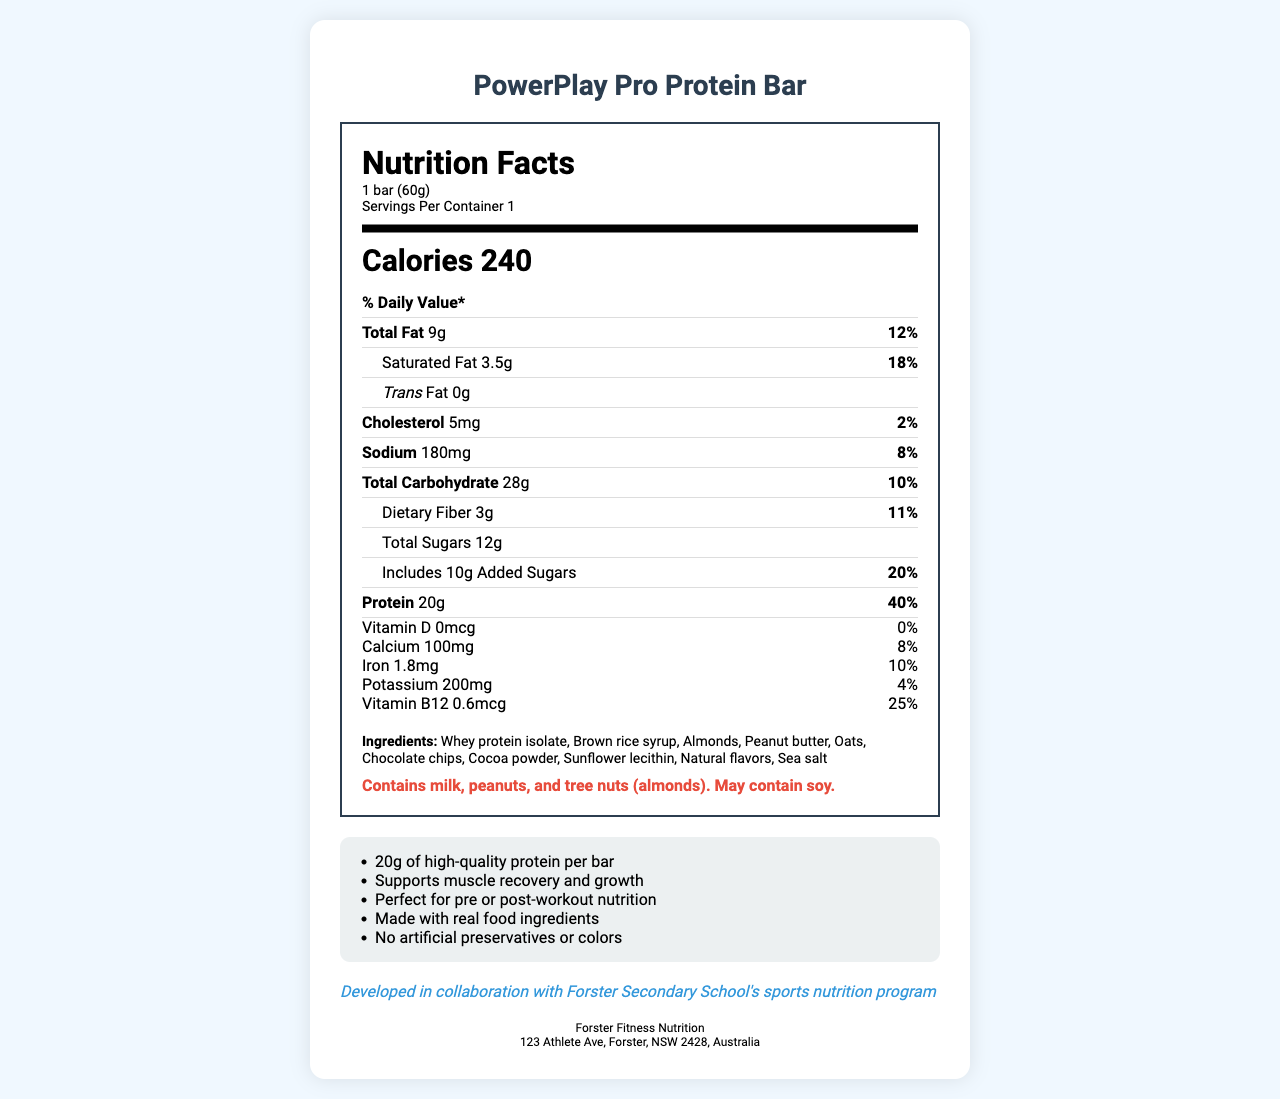what is the product name? The product name is stated at the top of the document under "Nutrition Facts: PowerPlay Pro Protein Bar".
Answer: PowerPlay Pro Protein Bar what is the serving size for the protein bar? The serving size is mentioned under the "Nutrition Facts" section as "1 bar (60g)".
Answer: 1 bar (60g) how many calories are in one bar? The number of calories per bar is displayed prominently under the "Nutrition Facts" section as "Calories 240".
Answer: 240 how much total fat is in one serving, and what is its daily value percentage? The total fat content is listed as "Total Fat 9g" and the daily value percentage is "12%" in the "Nutrition Facts" section.
Answer: 9g, 12% what are the main ingredients in the protein bar? The ingredients are listed at the bottom of the "Nutrition Facts" label under the "Ingredients" section.
Answer: Whey protein isolate, Brown rice syrup, Almonds, Peanut butter, Oats, Chocolate chips, Cocoa powder, Sunflower lecithin, Natural flavors, Sea salt what marketing claims are made about the protein bar? The marketing claims are listed in a section below the "Nutrition Facts" label.
Answer: 20g of high-quality protein per bar; Supports muscle recovery and growth; Perfect for pre or post-workout nutrition; Made with real food ingredients; No artificial preservatives or colors where is the manufacturer located? The manufacturer's address is provided at the bottom of the document.
Answer: 123 Athlete Ave, Forster, NSW 2428, Australia which mineral provides the highest percentage of daily value in one bar? According to the "Nutrition Facts" label, protein provides 40% of the daily value, which is the highest among the listed nutrients.
Answer: Protein (40%) how much sodium does the protein bar contain? The sodium content is listed in the "Nutrition Facts" as 180mg.
Answer: 180mg does this protein bar contain any allergens? The allergen information is stated under the "Nutrition Facts" label and indicates that the bar contains milk, peanuts, and tree nuts (almonds).
Answer: Yes what percentage of daily value of calcium does the bar provide? A. 4% B. 8% C. 10% D. 18% The "Nutrition Facts" section indicates that the calcium content provides 8% of the daily value.
Answer: B how many grams of dietary fiber does the bar contain per serving? A. 1g B. 2g C. 3g D. 4g The amount of dietary fiber per serving is listed as 3g in the "Nutrition Facts" label.
Answer: C is the protein bar suitable for a vegan diet? As per the ingredients list, the bar contains whey protein isolate, which is derived from milk, making it unsuitable for a vegan diet.
Answer: No summarize the main idea of the document. The nutrition facts label provides detailed nutritional information, including calories, fat, protein, vitamins, and minerals per serving. It also lists ingredients and allergen info, emphasizes real food ingredients, and suggests the bar’s use for muscle recovery and growth. The document mentions that the bar was developed in collaboration with Forster Secondary School’s sports nutrition program.
Answer: The document is a nutrition facts label for "PowerPlay Pro Protein Bar," highlighting the bar's nutritional content, ingredients, allergen information, and marketing claims. It is designed as a high-protein snack for athletes, particularly suitable for pre or post-workout nutrition. what is the contact email of the manufacturer? The document does not provide an email address for the manufacturer.
Answer: Cannot be determined 